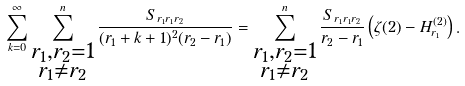Convert formula to latex. <formula><loc_0><loc_0><loc_500><loc_500>\sum _ { k = 0 } ^ { \infty } \sum _ { \substack { { r _ { 1 } , r _ { 2 } = 1 } \\ r _ { 1 } \ne r _ { 2 } } } ^ { n } \frac { S _ { r _ { 1 } r _ { 1 } r _ { 2 } } } { ( r _ { 1 } + k + 1 ) ^ { 2 } ( r _ { 2 } - r _ { 1 } ) } = \sum _ { \substack { { r _ { 1 } , r _ { 2 } = 1 } \\ r _ { 1 } \ne r _ { 2 } } } ^ { n } \frac { S _ { r _ { 1 } r _ { 1 } r _ { 2 } } } { r _ { 2 } - r _ { 1 } } \left ( \zeta ( 2 ) - H ^ { ( 2 ) } _ { r _ { 1 } } \right ) .</formula> 